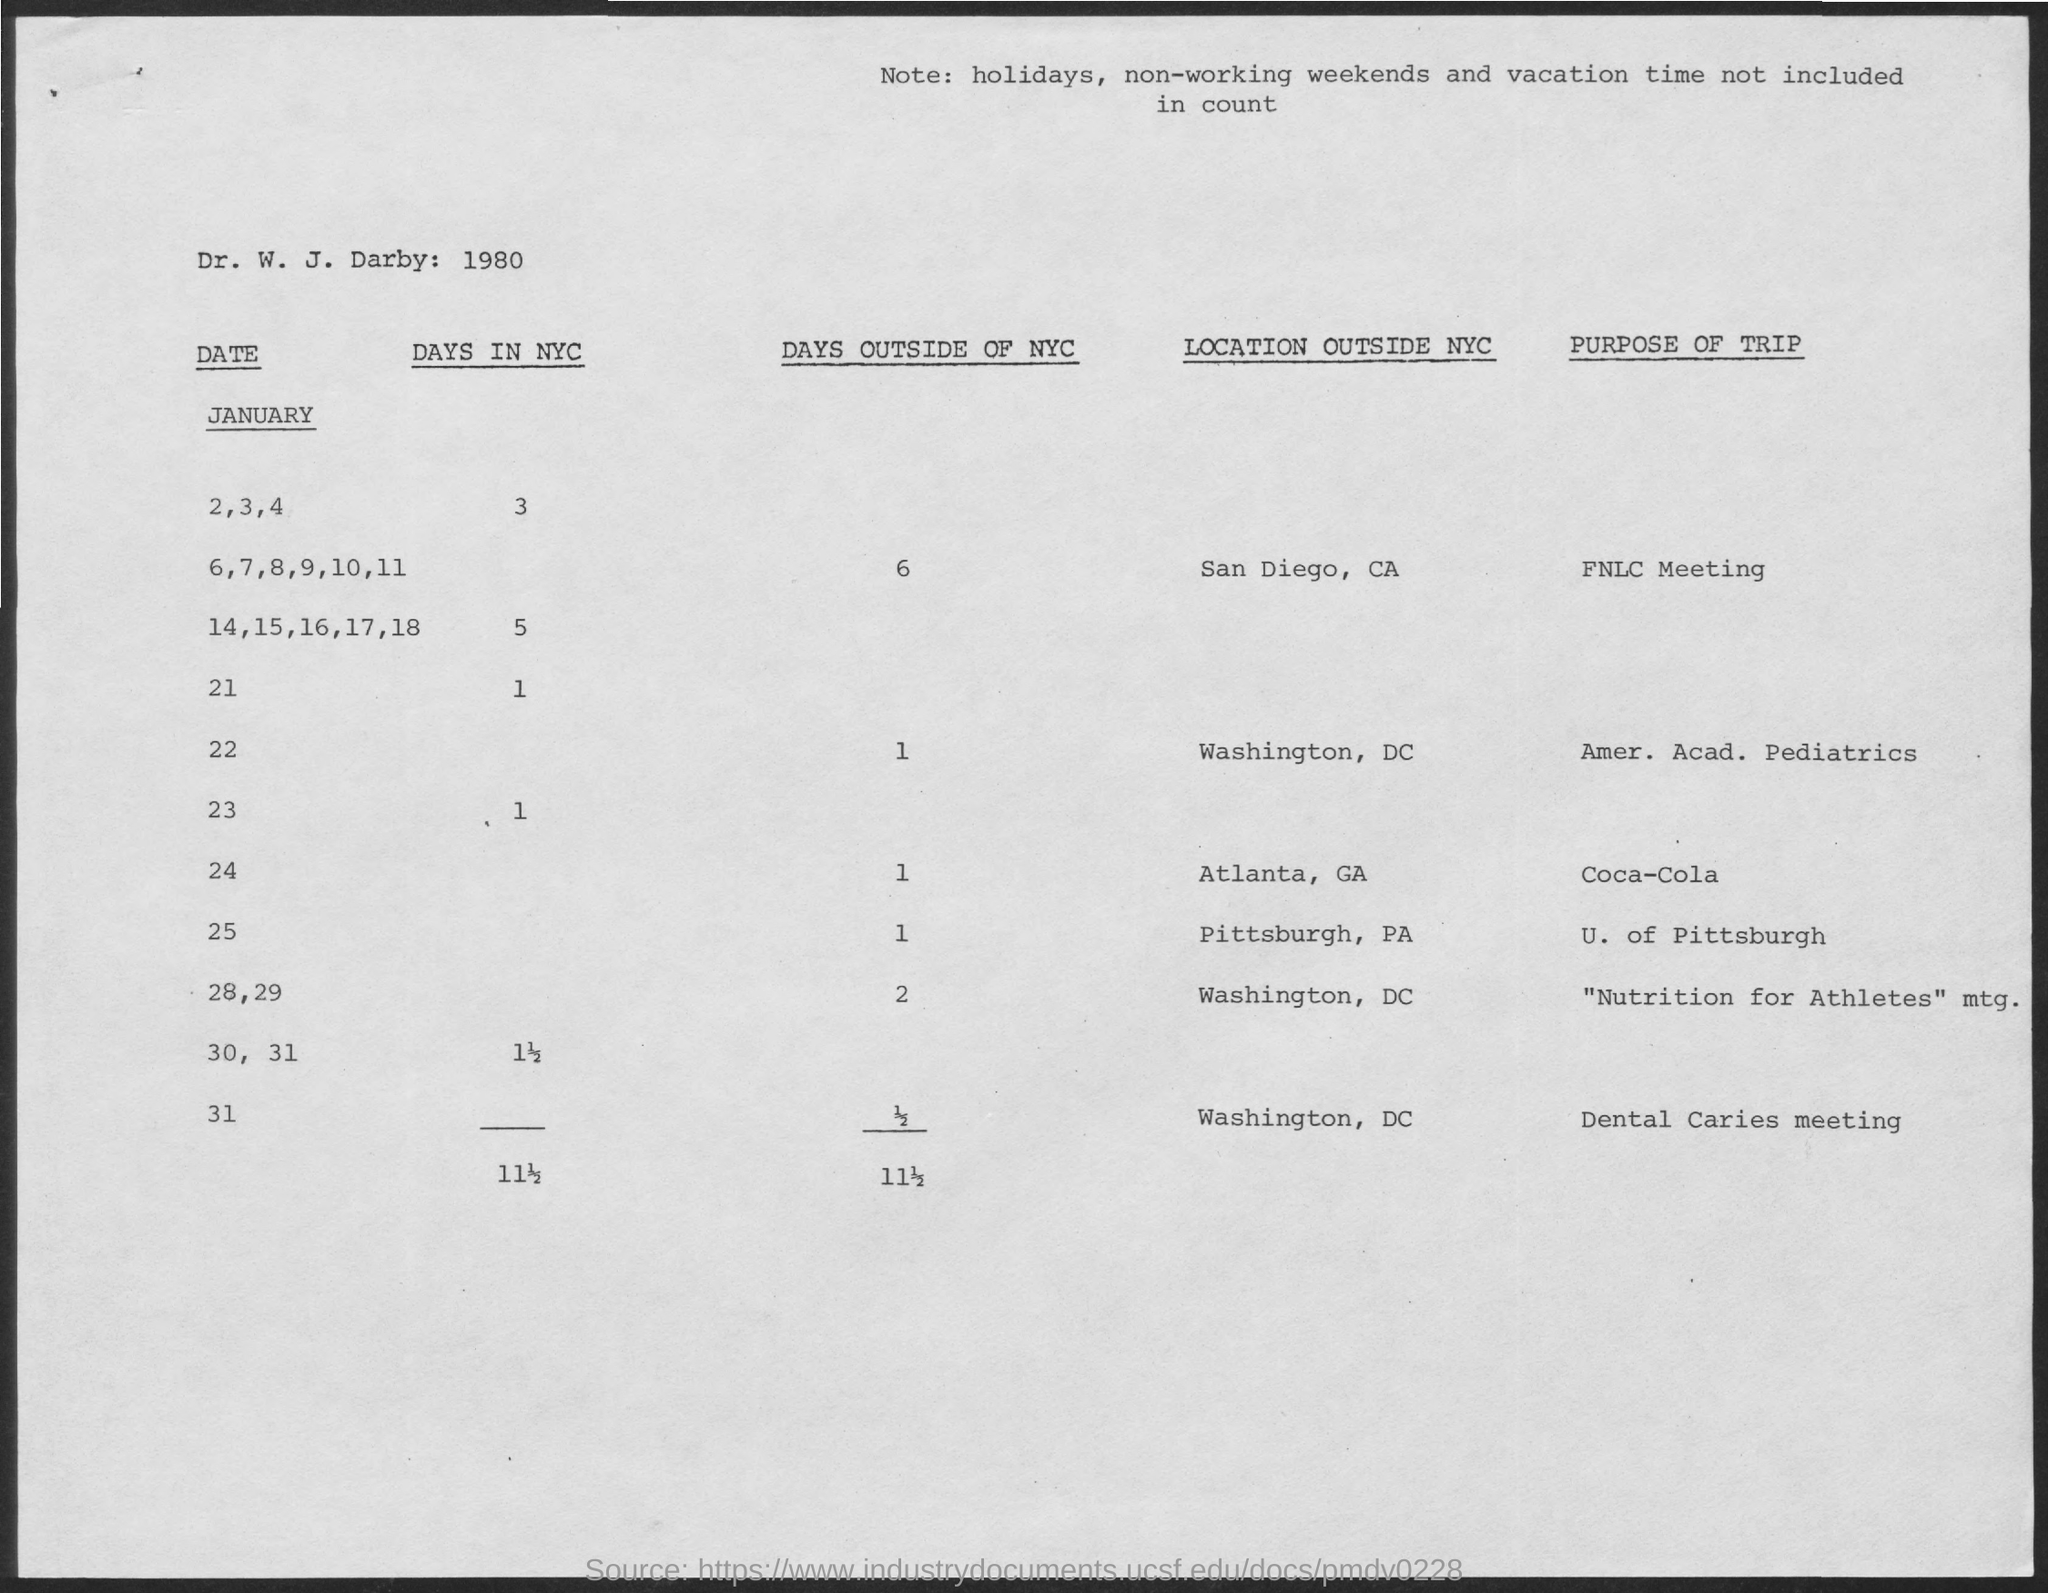Outline some significant characteristics in this image. The purpose of the trip on January 24 is to visit Coca-Cola. 